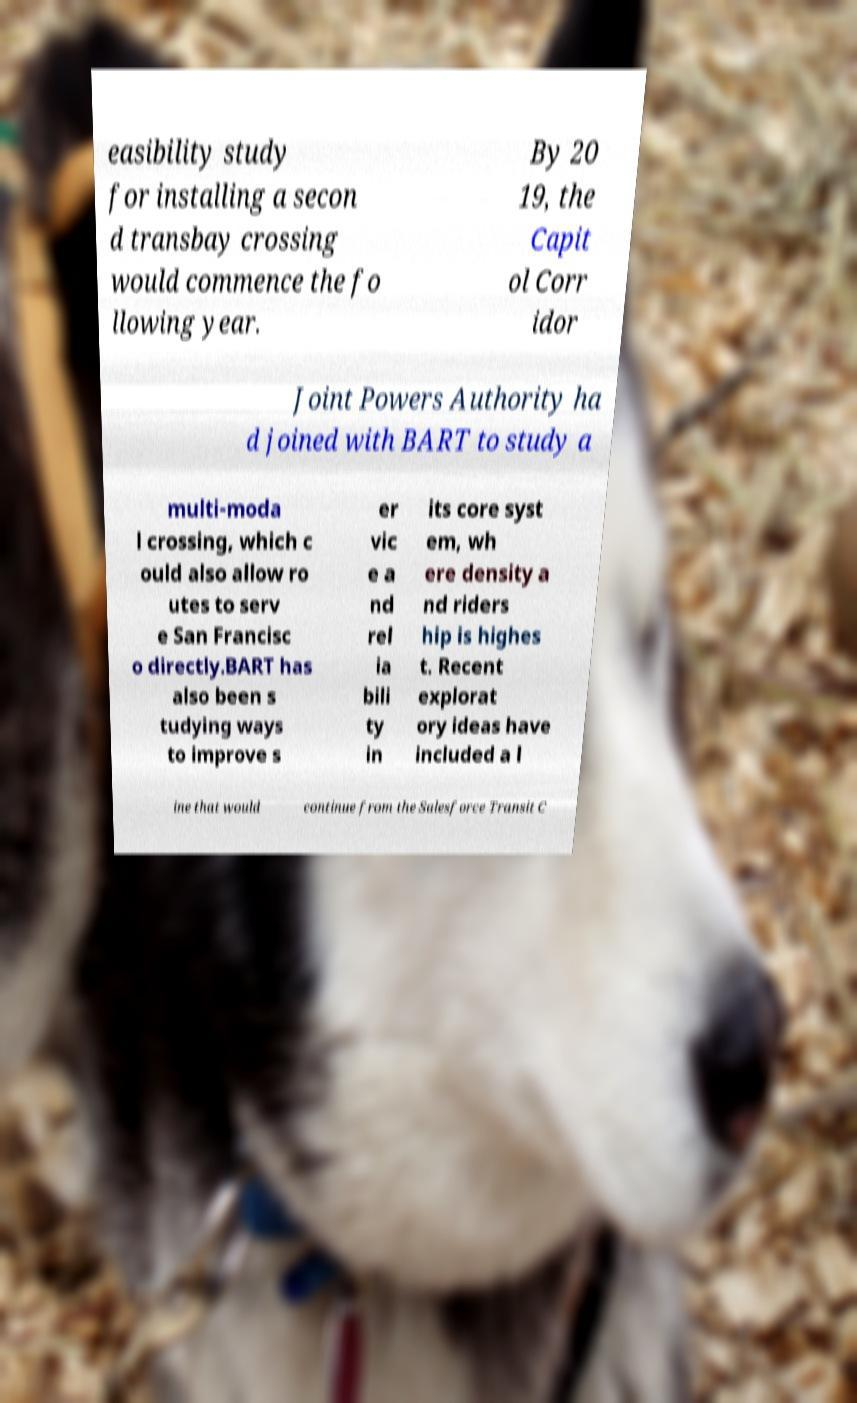Please read and relay the text visible in this image. What does it say? easibility study for installing a secon d transbay crossing would commence the fo llowing year. By 20 19, the Capit ol Corr idor Joint Powers Authority ha d joined with BART to study a multi-moda l crossing, which c ould also allow ro utes to serv e San Francisc o directly.BART has also been s tudying ways to improve s er vic e a nd rel ia bili ty in its core syst em, wh ere density a nd riders hip is highes t. Recent explorat ory ideas have included a l ine that would continue from the Salesforce Transit C 